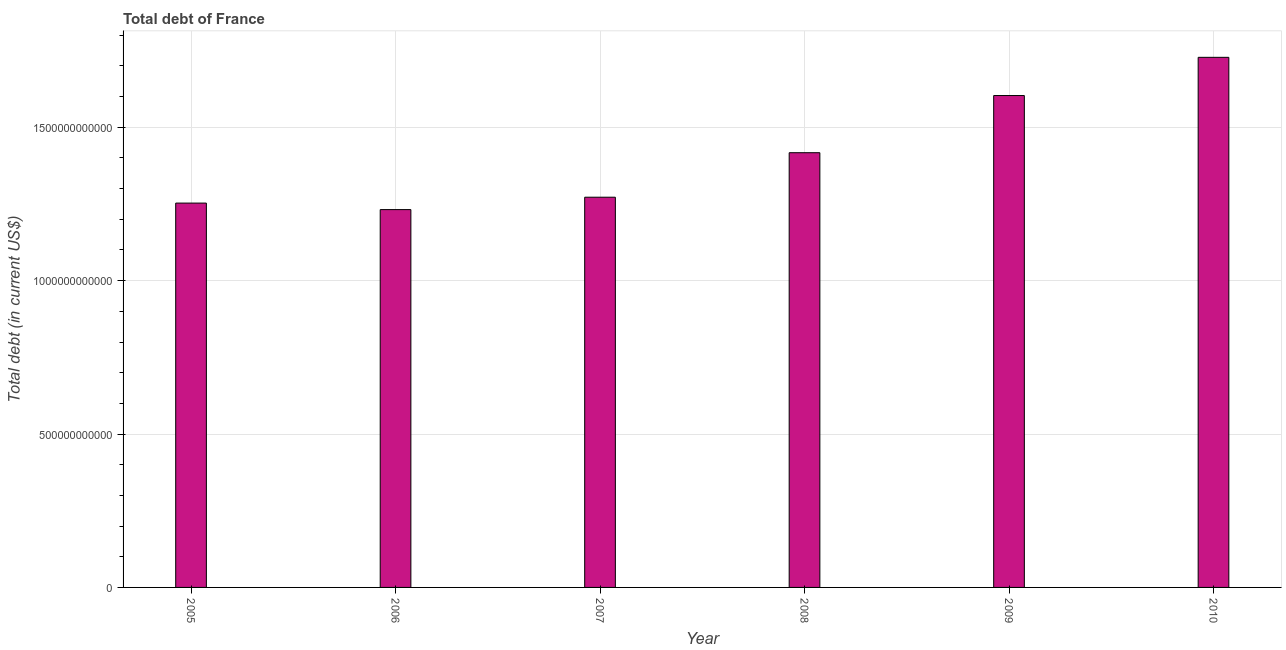Does the graph contain any zero values?
Your answer should be very brief. No. Does the graph contain grids?
Your response must be concise. Yes. What is the title of the graph?
Provide a short and direct response. Total debt of France. What is the label or title of the Y-axis?
Your response must be concise. Total debt (in current US$). What is the total debt in 2009?
Your response must be concise. 1.60e+12. Across all years, what is the maximum total debt?
Ensure brevity in your answer.  1.73e+12. Across all years, what is the minimum total debt?
Ensure brevity in your answer.  1.23e+12. In which year was the total debt maximum?
Ensure brevity in your answer.  2010. In which year was the total debt minimum?
Provide a short and direct response. 2006. What is the sum of the total debt?
Provide a succinct answer. 8.50e+12. What is the difference between the total debt in 2009 and 2010?
Give a very brief answer. -1.25e+11. What is the average total debt per year?
Offer a very short reply. 1.42e+12. What is the median total debt?
Your answer should be compact. 1.34e+12. In how many years, is the total debt greater than 1700000000000 US$?
Keep it short and to the point. 1. Do a majority of the years between 2010 and 2005 (inclusive) have total debt greater than 1200000000000 US$?
Your answer should be compact. Yes. What is the ratio of the total debt in 2007 to that in 2008?
Make the answer very short. 0.9. Is the total debt in 2007 less than that in 2009?
Offer a terse response. Yes. What is the difference between the highest and the second highest total debt?
Your response must be concise. 1.25e+11. What is the difference between the highest and the lowest total debt?
Keep it short and to the point. 4.96e+11. What is the difference between two consecutive major ticks on the Y-axis?
Your answer should be very brief. 5.00e+11. What is the Total debt (in current US$) of 2005?
Your response must be concise. 1.25e+12. What is the Total debt (in current US$) in 2006?
Make the answer very short. 1.23e+12. What is the Total debt (in current US$) in 2007?
Make the answer very short. 1.27e+12. What is the Total debt (in current US$) in 2008?
Ensure brevity in your answer.  1.42e+12. What is the Total debt (in current US$) of 2009?
Ensure brevity in your answer.  1.60e+12. What is the Total debt (in current US$) in 2010?
Offer a very short reply. 1.73e+12. What is the difference between the Total debt (in current US$) in 2005 and 2006?
Give a very brief answer. 2.13e+1. What is the difference between the Total debt (in current US$) in 2005 and 2007?
Provide a succinct answer. -1.91e+1. What is the difference between the Total debt (in current US$) in 2005 and 2008?
Give a very brief answer. -1.64e+11. What is the difference between the Total debt (in current US$) in 2005 and 2009?
Provide a succinct answer. -3.51e+11. What is the difference between the Total debt (in current US$) in 2005 and 2010?
Your answer should be compact. -4.75e+11. What is the difference between the Total debt (in current US$) in 2006 and 2007?
Your answer should be compact. -4.04e+1. What is the difference between the Total debt (in current US$) in 2006 and 2008?
Give a very brief answer. -1.85e+11. What is the difference between the Total debt (in current US$) in 2006 and 2009?
Ensure brevity in your answer.  -3.72e+11. What is the difference between the Total debt (in current US$) in 2006 and 2010?
Your answer should be compact. -4.96e+11. What is the difference between the Total debt (in current US$) in 2007 and 2008?
Your answer should be very brief. -1.45e+11. What is the difference between the Total debt (in current US$) in 2007 and 2009?
Keep it short and to the point. -3.31e+11. What is the difference between the Total debt (in current US$) in 2007 and 2010?
Provide a succinct answer. -4.56e+11. What is the difference between the Total debt (in current US$) in 2008 and 2009?
Provide a succinct answer. -1.86e+11. What is the difference between the Total debt (in current US$) in 2008 and 2010?
Keep it short and to the point. -3.11e+11. What is the difference between the Total debt (in current US$) in 2009 and 2010?
Your response must be concise. -1.25e+11. What is the ratio of the Total debt (in current US$) in 2005 to that in 2006?
Give a very brief answer. 1.02. What is the ratio of the Total debt (in current US$) in 2005 to that in 2007?
Your answer should be very brief. 0.98. What is the ratio of the Total debt (in current US$) in 2005 to that in 2008?
Your answer should be compact. 0.88. What is the ratio of the Total debt (in current US$) in 2005 to that in 2009?
Make the answer very short. 0.78. What is the ratio of the Total debt (in current US$) in 2005 to that in 2010?
Your answer should be compact. 0.72. What is the ratio of the Total debt (in current US$) in 2006 to that in 2008?
Give a very brief answer. 0.87. What is the ratio of the Total debt (in current US$) in 2006 to that in 2009?
Offer a very short reply. 0.77. What is the ratio of the Total debt (in current US$) in 2006 to that in 2010?
Provide a short and direct response. 0.71. What is the ratio of the Total debt (in current US$) in 2007 to that in 2008?
Your answer should be very brief. 0.9. What is the ratio of the Total debt (in current US$) in 2007 to that in 2009?
Make the answer very short. 0.79. What is the ratio of the Total debt (in current US$) in 2007 to that in 2010?
Your answer should be very brief. 0.74. What is the ratio of the Total debt (in current US$) in 2008 to that in 2009?
Provide a succinct answer. 0.88. What is the ratio of the Total debt (in current US$) in 2008 to that in 2010?
Ensure brevity in your answer.  0.82. What is the ratio of the Total debt (in current US$) in 2009 to that in 2010?
Your answer should be compact. 0.93. 